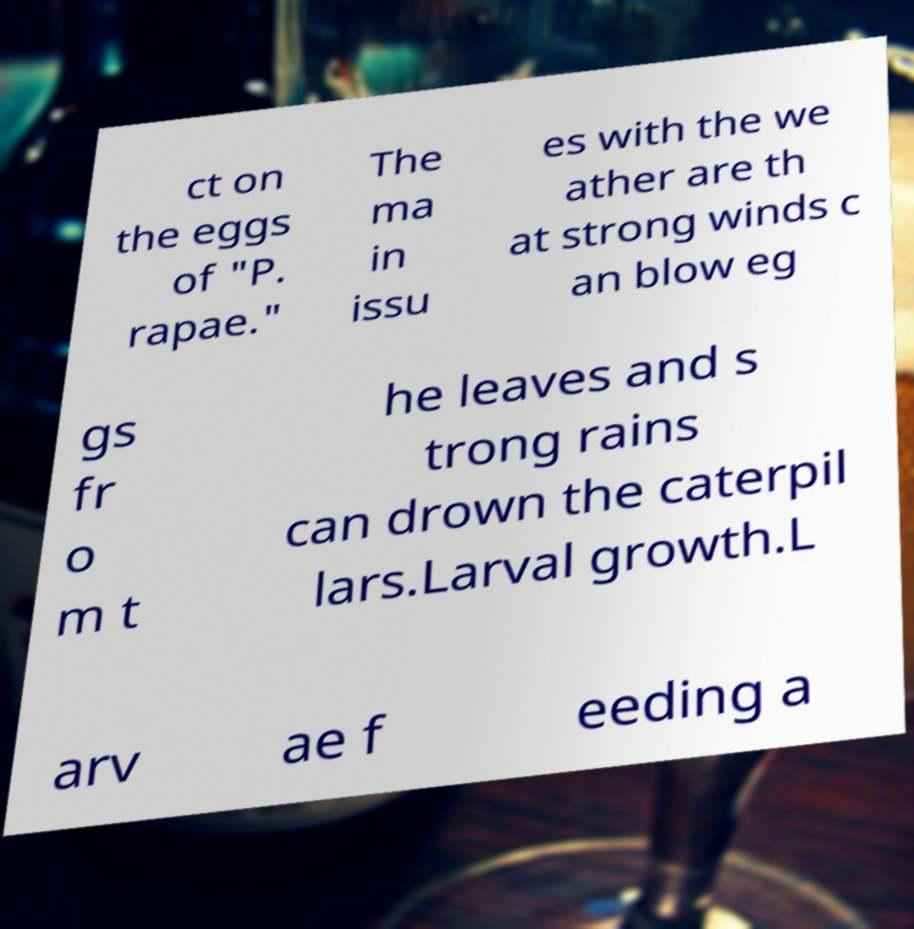There's text embedded in this image that I need extracted. Can you transcribe it verbatim? ct on the eggs of "P. rapae." The ma in issu es with the we ather are th at strong winds c an blow eg gs fr o m t he leaves and s trong rains can drown the caterpil lars.Larval growth.L arv ae f eeding a 